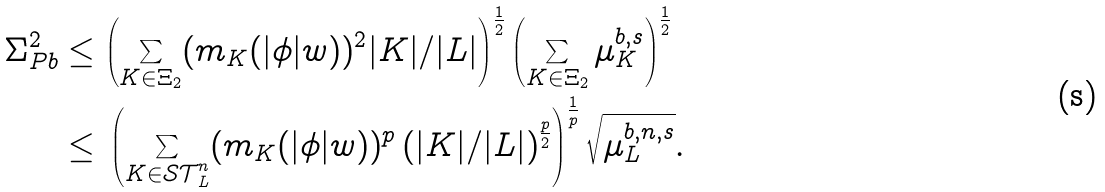Convert formula to latex. <formula><loc_0><loc_0><loc_500><loc_500>\Sigma ^ { 2 } _ { P b } & \leq \left ( \sum _ { K \in \Xi _ { 2 } } ( m _ { K } ( | \phi | w ) ) ^ { 2 } { | K | } / { | L | } \right ) ^ { \frac { 1 } { 2 } } \left ( \sum _ { K \in \Xi _ { 2 } } \mu ^ { b , s } _ { K } \right ) ^ { \frac { 1 } { 2 } } \\ & \leq \, \left ( \sum _ { K \in \mathcal { S T } ^ { n } _ { L } } ( m _ { K } ( | \phi | w ) ) ^ { p } \left ( { | K | / | L | } \right ) ^ { \frac { p } { 2 } } \right ) ^ { \frac { 1 } { p } } \sqrt { \mu ^ { b , n , s } _ { L } } .</formula> 